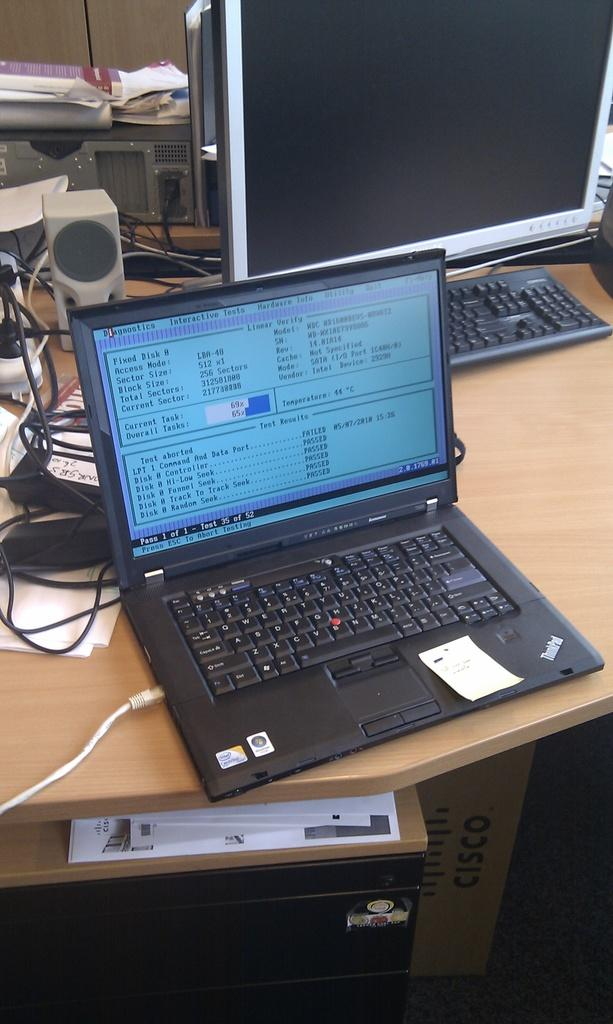Provide a one-sentence caption for the provided image. a lap top computer open to a screen for "test results" reading Passed. 